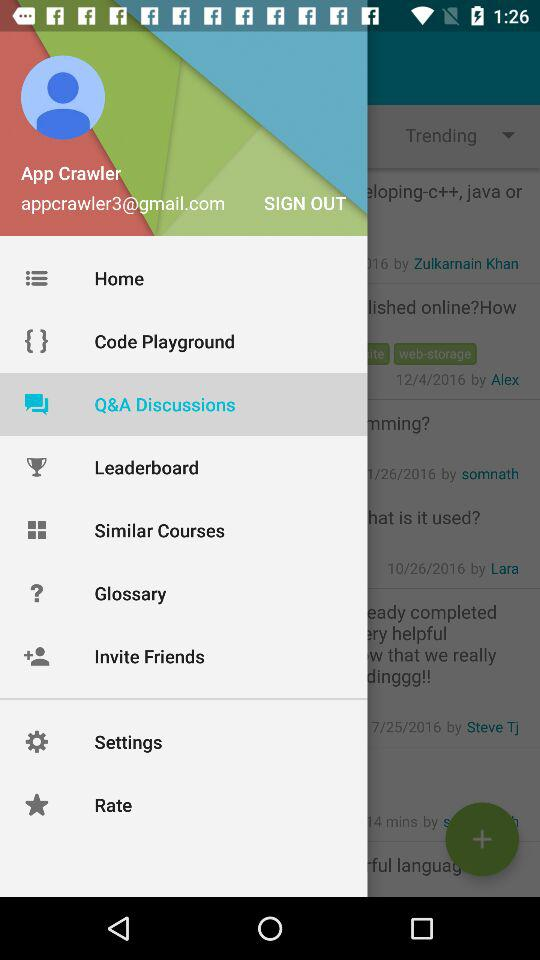What's the Gmail address? The Gmail address is appcrawler3@gmail.com. 